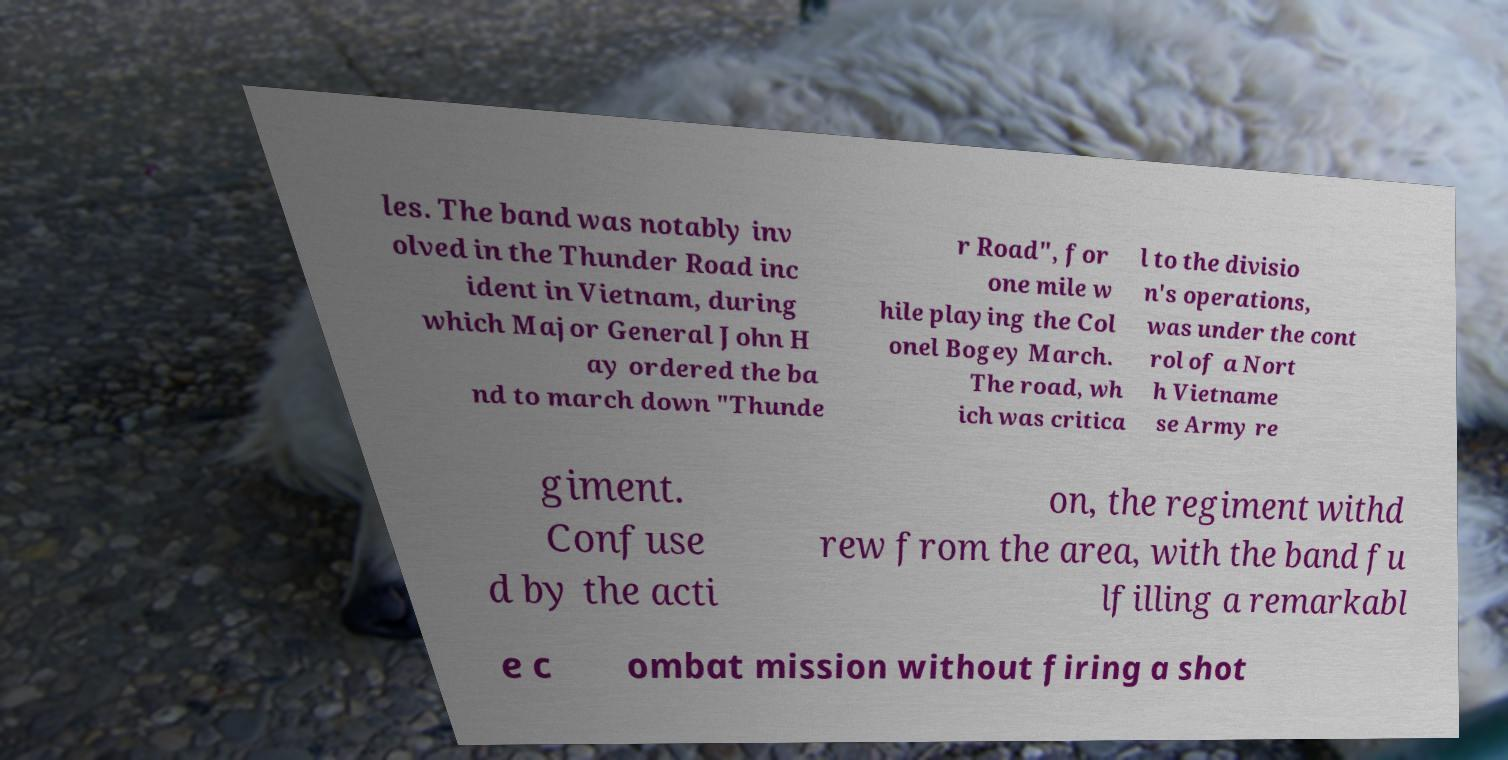Please identify and transcribe the text found in this image. les. The band was notably inv olved in the Thunder Road inc ident in Vietnam, during which Major General John H ay ordered the ba nd to march down "Thunde r Road", for one mile w hile playing the Col onel Bogey March. The road, wh ich was critica l to the divisio n's operations, was under the cont rol of a Nort h Vietname se Army re giment. Confuse d by the acti on, the regiment withd rew from the area, with the band fu lfilling a remarkabl e c ombat mission without firing a shot 